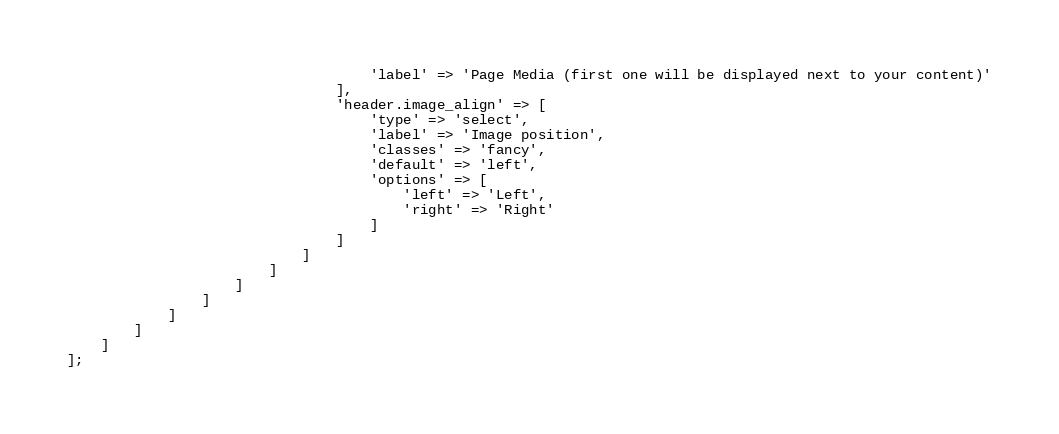<code> <loc_0><loc_0><loc_500><loc_500><_PHP_>                                    'label' => 'Page Media (first one will be displayed next to your content)'
                                ],
                                'header.image_align' => [
                                    'type' => 'select',
                                    'label' => 'Image position',
                                    'classes' => 'fancy',
                                    'default' => 'left',
                                    'options' => [
                                        'left' => 'Left',
                                        'right' => 'Right'
                                    ]
                                ]
                            ]
                        ]
                    ]
                ]
            ]
        ]
    ]
];
</code> 